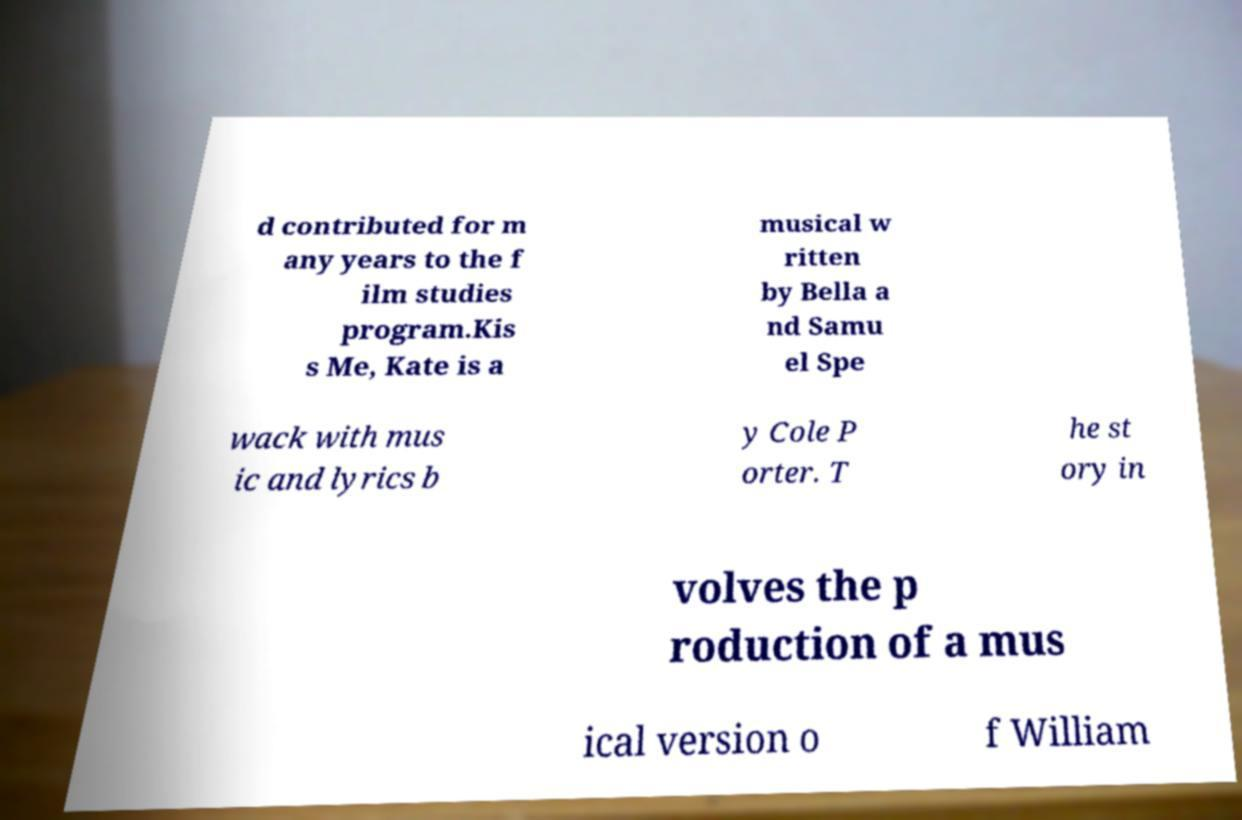Can you read and provide the text displayed in the image?This photo seems to have some interesting text. Can you extract and type it out for me? d contributed for m any years to the f ilm studies program.Kis s Me, Kate is a musical w ritten by Bella a nd Samu el Spe wack with mus ic and lyrics b y Cole P orter. T he st ory in volves the p roduction of a mus ical version o f William 